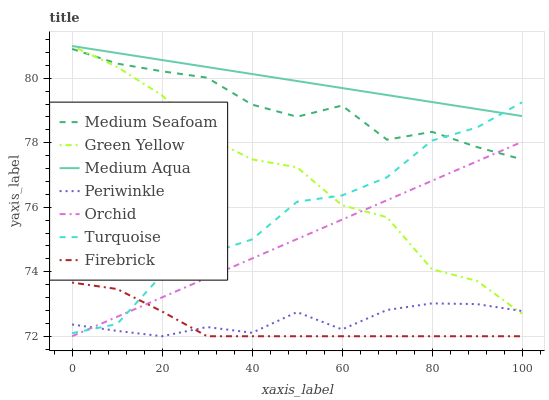Does Firebrick have the minimum area under the curve?
Answer yes or no. Yes. Does Medium Aqua have the maximum area under the curve?
Answer yes or no. Yes. Does Periwinkle have the minimum area under the curve?
Answer yes or no. No. Does Periwinkle have the maximum area under the curve?
Answer yes or no. No. Is Orchid the smoothest?
Answer yes or no. Yes. Is Green Yellow the roughest?
Answer yes or no. Yes. Is Firebrick the smoothest?
Answer yes or no. No. Is Firebrick the roughest?
Answer yes or no. No. Does Firebrick have the lowest value?
Answer yes or no. Yes. Does Medium Aqua have the lowest value?
Answer yes or no. No. Does Green Yellow have the highest value?
Answer yes or no. Yes. Does Firebrick have the highest value?
Answer yes or no. No. Is Medium Seafoam less than Medium Aqua?
Answer yes or no. Yes. Is Medium Seafoam greater than Periwinkle?
Answer yes or no. Yes. Does Green Yellow intersect Medium Seafoam?
Answer yes or no. Yes. Is Green Yellow less than Medium Seafoam?
Answer yes or no. No. Is Green Yellow greater than Medium Seafoam?
Answer yes or no. No. Does Medium Seafoam intersect Medium Aqua?
Answer yes or no. No. 